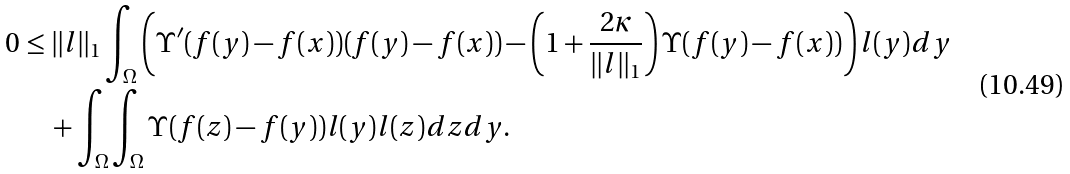<formula> <loc_0><loc_0><loc_500><loc_500>0 & \leq \| l \| _ { 1 } \int _ { \Omega } \left ( \Upsilon ^ { \prime } ( f ( y ) - f ( x ) ) ( f ( y ) - f ( x ) ) - \left ( 1 + \frac { 2 \kappa } { \| l \| _ { 1 } } \right ) \Upsilon ( f ( y ) - f ( x ) ) \right ) l ( y ) d y \\ & \quad + \int _ { \Omega } \int _ { \Omega } \Upsilon ( f ( z ) - f ( y ) ) l ( y ) l ( z ) d z d y .</formula> 